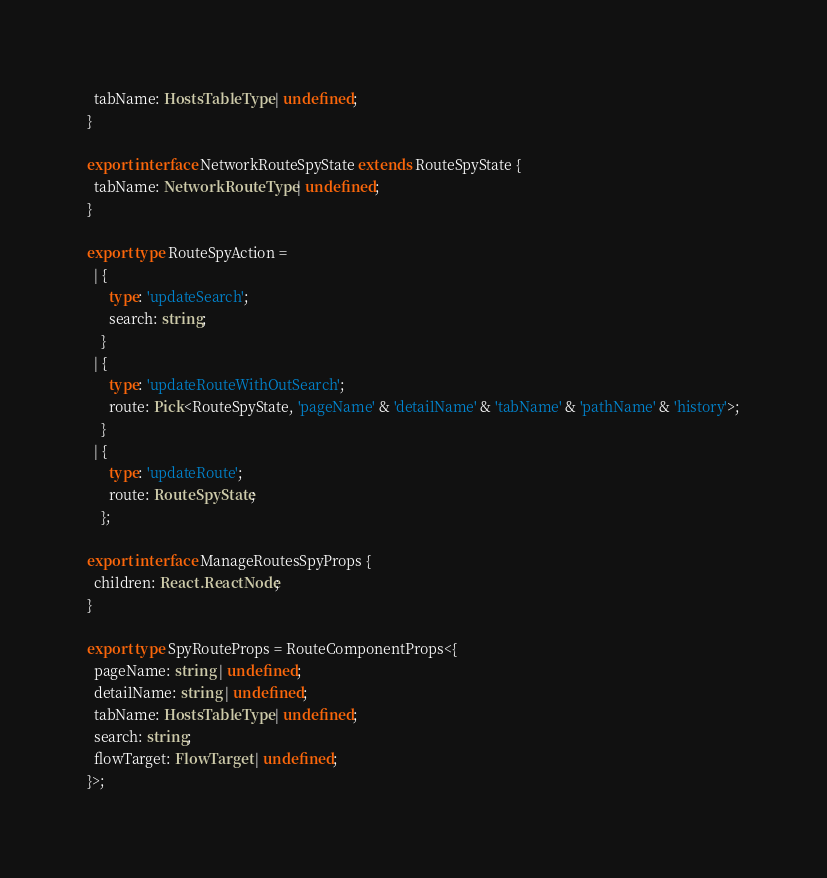<code> <loc_0><loc_0><loc_500><loc_500><_TypeScript_>  tabName: HostsTableType | undefined;
}

export interface NetworkRouteSpyState extends RouteSpyState {
  tabName: NetworkRouteType | undefined;
}

export type RouteSpyAction =
  | {
      type: 'updateSearch';
      search: string;
    }
  | {
      type: 'updateRouteWithOutSearch';
      route: Pick<RouteSpyState, 'pageName' & 'detailName' & 'tabName' & 'pathName' & 'history'>;
    }
  | {
      type: 'updateRoute';
      route: RouteSpyState;
    };

export interface ManageRoutesSpyProps {
  children: React.ReactNode;
}

export type SpyRouteProps = RouteComponentProps<{
  pageName: string | undefined;
  detailName: string | undefined;
  tabName: HostsTableType | undefined;
  search: string;
  flowTarget: FlowTarget | undefined;
}>;
</code> 